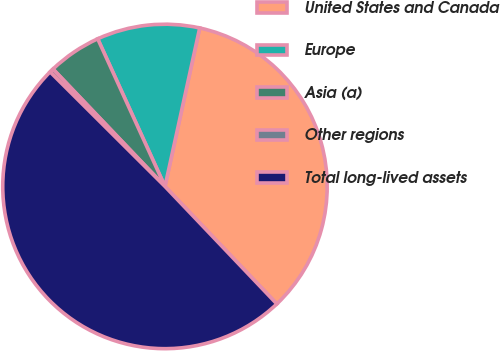Convert chart. <chart><loc_0><loc_0><loc_500><loc_500><pie_chart><fcel>United States and Canada<fcel>Europe<fcel>Asia (a)<fcel>Other regions<fcel>Total long-lived assets<nl><fcel>34.46%<fcel>10.24%<fcel>5.32%<fcel>0.4%<fcel>49.59%<nl></chart> 